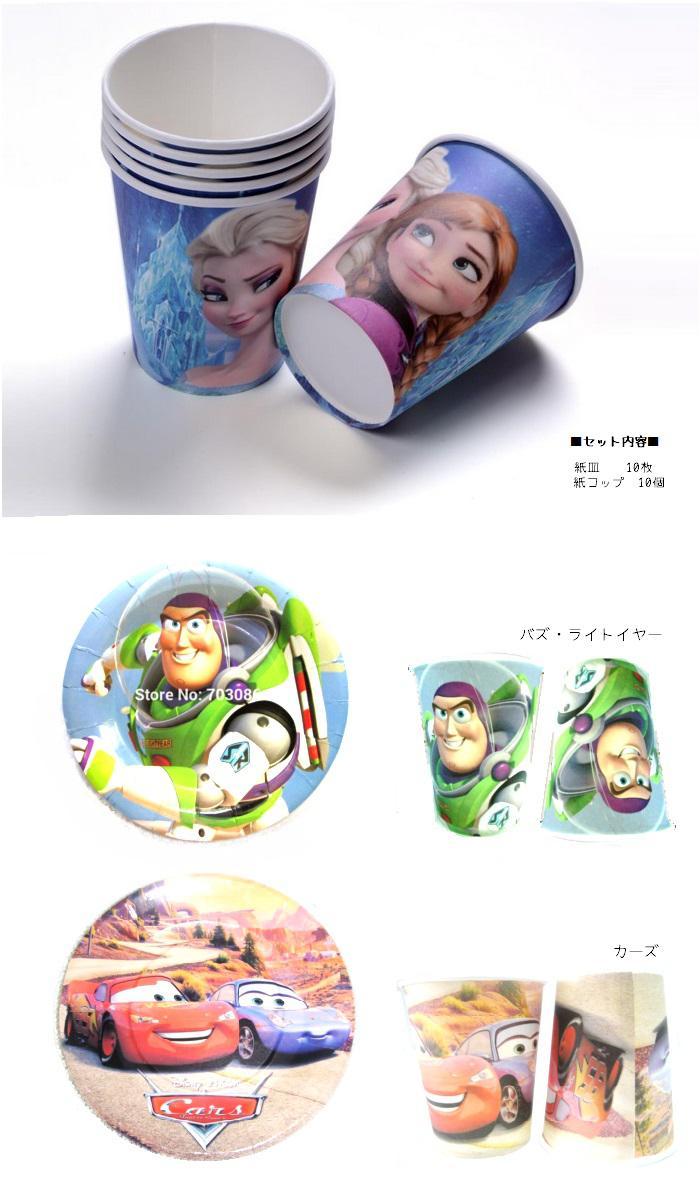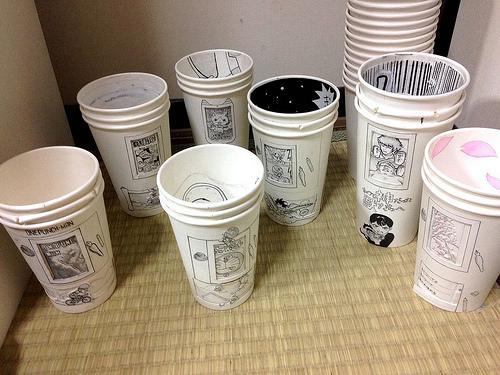The first image is the image on the left, the second image is the image on the right. Analyze the images presented: Is the assertion "In at least one image there are three paper cups." valid? Answer yes or no. No. The first image is the image on the left, the second image is the image on the right. Given the left and right images, does the statement "The left image shows a thumb on the left side of a cup, and the right image includes a cup with a cartoon face on it and contains no more than two cups." hold true? Answer yes or no. No. 